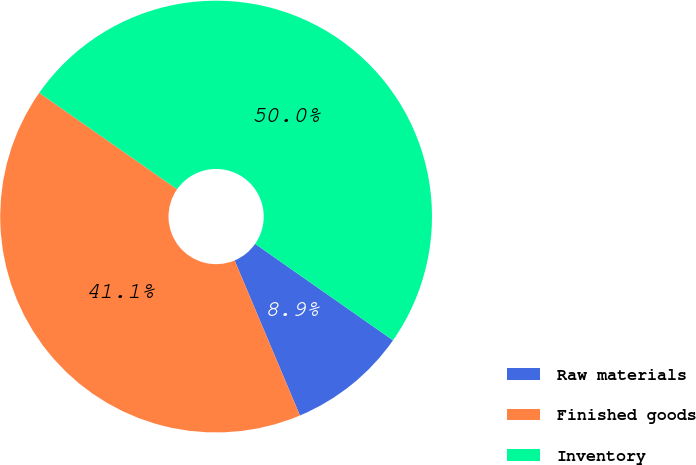Convert chart to OTSL. <chart><loc_0><loc_0><loc_500><loc_500><pie_chart><fcel>Raw materials<fcel>Finished goods<fcel>Inventory<nl><fcel>8.94%<fcel>41.06%<fcel>50.0%<nl></chart> 